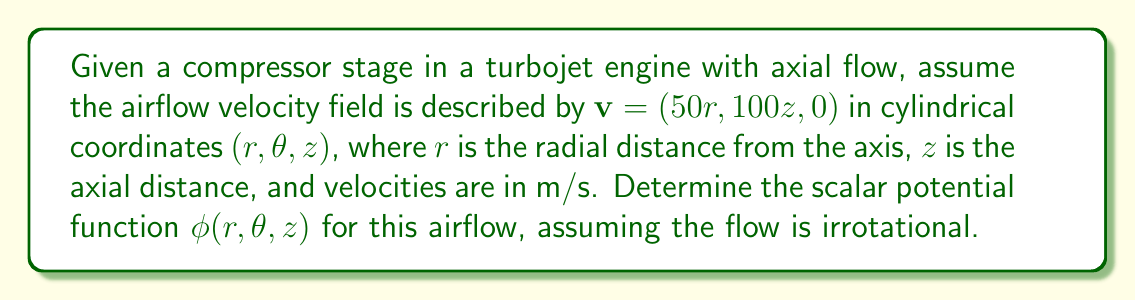What is the answer to this math problem? To determine the scalar potential function, we follow these steps:

1) For an irrotational flow, the velocity field $\mathbf{v}$ can be expressed as the gradient of a scalar potential $\phi$:

   $\mathbf{v} = \nabla\phi$

2) In cylindrical coordinates, the gradient operator is:

   $\nabla\phi = \frac{\partial\phi}{\partial r}\hat{r} + \frac{1}{r}\frac{\partial\phi}{\partial\theta}\hat{\theta} + \frac{\partial\phi}{\partial z}\hat{z}$

3) Comparing this with the given velocity field:

   $\mathbf{v} = (50r, 100z, 0) = 50r\hat{r} + 100z\hat{z}$

4) We can equate the components:

   $\frac{\partial\phi}{\partial r} = 50r$
   $\frac{1}{r}\frac{\partial\phi}{\partial\theta} = 0$
   $\frac{\partial\phi}{\partial z} = 100z$

5) Integrating the first equation with respect to $r$:

   $\phi = 25r^2 + f(z)$

6) Integrating the third equation with respect to $z$:

   $\phi = 50z^2 + g(r)$

7) Combining these results:

   $\phi(r,\theta,z) = 25r^2 + 50z^2 + C$

   where $C$ is an arbitrary constant.

8) We can verify that this potential satisfies the original velocity field:

   $\frac{\partial\phi}{\partial r} = 50r$
   $\frac{\partial\phi}{\partial z} = 100z$
   $\frac{\partial\phi}{\partial\theta} = 0$

   which matches the given velocity components.
Answer: $\phi(r,\theta,z) = 25r^2 + 50z^2 + C$ 